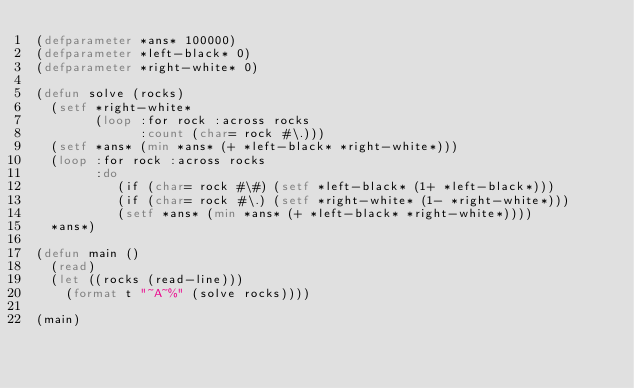Convert code to text. <code><loc_0><loc_0><loc_500><loc_500><_Lisp_>(defparameter *ans* 100000)
(defparameter *left-black* 0)
(defparameter *right-white* 0)

(defun solve (rocks)
  (setf *right-white*
        (loop :for rock :across rocks
              :count (char= rock #\.)))
  (setf *ans* (min *ans* (+ *left-black* *right-white*)))
  (loop :for rock :across rocks
        :do
           (if (char= rock #\#) (setf *left-black* (1+ *left-black*)))
           (if (char= rock #\.) (setf *right-white* (1- *right-white*)))
           (setf *ans* (min *ans* (+ *left-black* *right-white*))))
  *ans*)

(defun main ()
  (read)
  (let ((rocks (read-line)))
    (format t "~A~%" (solve rocks))))

(main)
</code> 